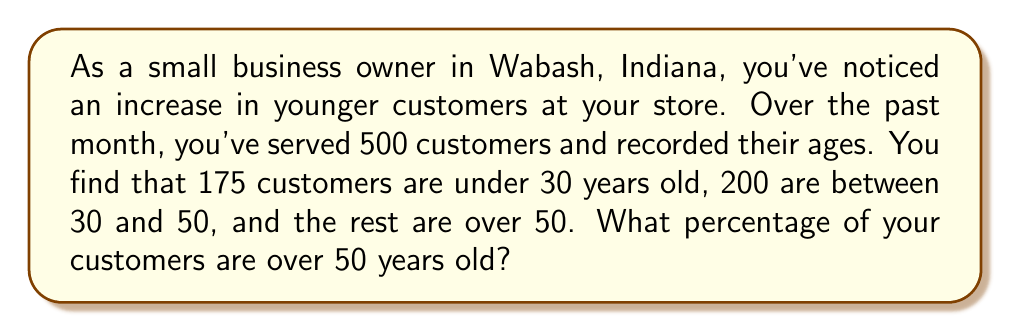Provide a solution to this math problem. Let's approach this step-by-step:

1. First, let's identify the known information:
   - Total customers: 500
   - Customers under 30: 175
   - Customers between 30 and 50: 200

2. To find the number of customers over 50, we subtract the known groups from the total:
   $500 - (175 + 200) = 500 - 375 = 125$ customers over 50

3. Now, to calculate the percentage, we use the formula:
   $\text{Percentage} = \frac{\text{Part}}{\text{Whole}} \times 100\%$

4. Plugging in our values:
   $$\text{Percentage} = \frac{125}{500} \times 100\%$$

5. Simplify the fraction:
   $$\frac{125}{500} = \frac{1}{4} = 0.25$$

6. Calculate the final percentage:
   $$0.25 \times 100\% = 25\%$$

Therefore, 25% of your customers are over 50 years old.
Answer: 25% 